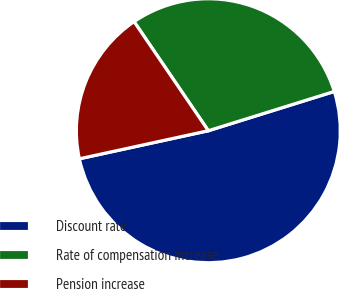Convert chart. <chart><loc_0><loc_0><loc_500><loc_500><pie_chart><fcel>Discount rate<fcel>Rate of compensation increase<fcel>Pension increase<nl><fcel>51.4%<fcel>29.7%<fcel>18.9%<nl></chart> 